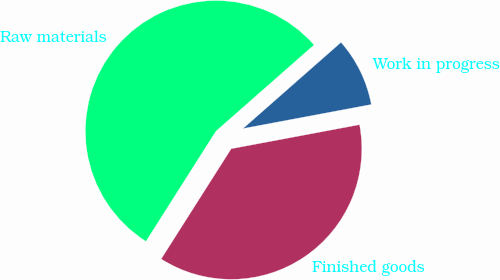<chart> <loc_0><loc_0><loc_500><loc_500><pie_chart><fcel>Finished goods<fcel>Work in progress<fcel>Raw materials<nl><fcel>36.96%<fcel>8.53%<fcel>54.51%<nl></chart> 